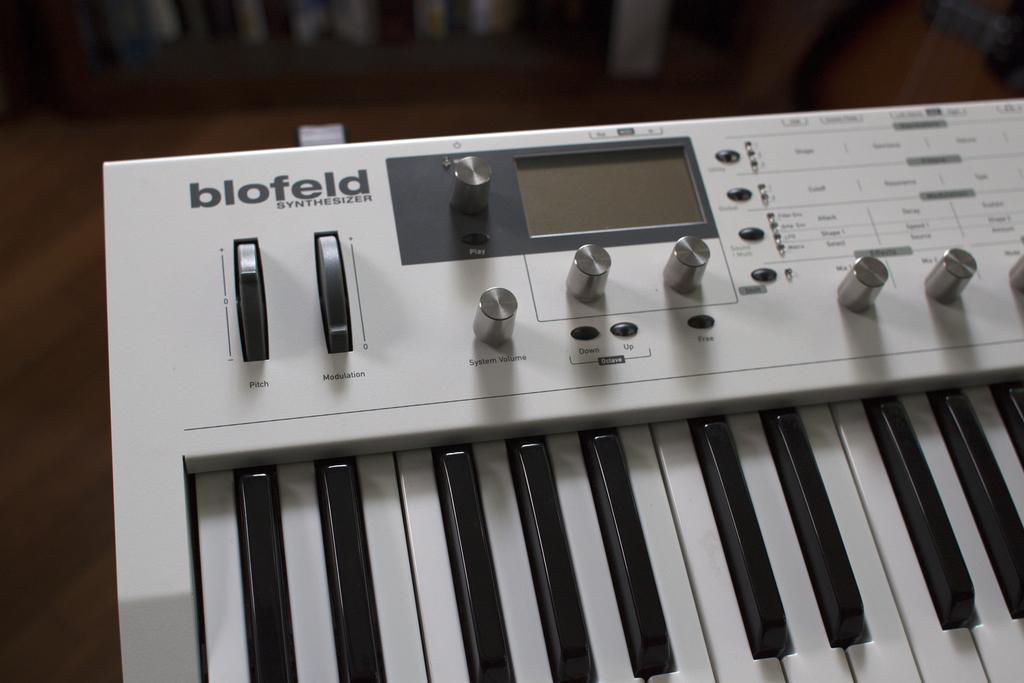In one or two sentences, can you explain what this image depicts? In this image we can see a musical instrument. In the background of the image there is a blur background. 